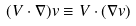<formula> <loc_0><loc_0><loc_500><loc_500>( { V } \cdot \nabla ) { v } \equiv V \cdot ( \nabla { v } )</formula> 